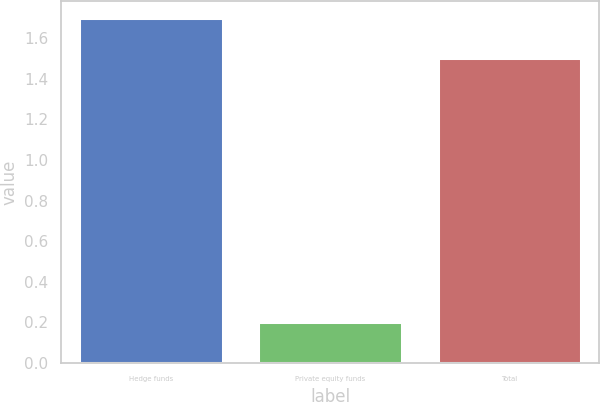<chart> <loc_0><loc_0><loc_500><loc_500><bar_chart><fcel>Hedge funds<fcel>Private equity funds<fcel>Total<nl><fcel>1.7<fcel>0.2<fcel>1.5<nl></chart> 